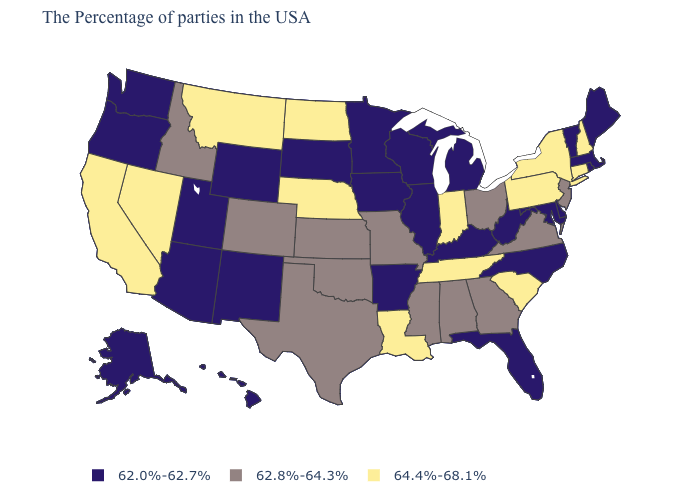Name the states that have a value in the range 62.0%-62.7%?
Short answer required. Maine, Massachusetts, Rhode Island, Vermont, Delaware, Maryland, North Carolina, West Virginia, Florida, Michigan, Kentucky, Wisconsin, Illinois, Arkansas, Minnesota, Iowa, South Dakota, Wyoming, New Mexico, Utah, Arizona, Washington, Oregon, Alaska, Hawaii. Does Pennsylvania have a lower value than Ohio?
Write a very short answer. No. Name the states that have a value in the range 62.0%-62.7%?
Answer briefly. Maine, Massachusetts, Rhode Island, Vermont, Delaware, Maryland, North Carolina, West Virginia, Florida, Michigan, Kentucky, Wisconsin, Illinois, Arkansas, Minnesota, Iowa, South Dakota, Wyoming, New Mexico, Utah, Arizona, Washington, Oregon, Alaska, Hawaii. Name the states that have a value in the range 64.4%-68.1%?
Be succinct. New Hampshire, Connecticut, New York, Pennsylvania, South Carolina, Indiana, Tennessee, Louisiana, Nebraska, North Dakota, Montana, Nevada, California. What is the value of Arizona?
Write a very short answer. 62.0%-62.7%. Does the first symbol in the legend represent the smallest category?
Concise answer only. Yes. What is the value of Connecticut?
Short answer required. 64.4%-68.1%. What is the value of West Virginia?
Quick response, please. 62.0%-62.7%. What is the value of Maine?
Short answer required. 62.0%-62.7%. Which states have the highest value in the USA?
Concise answer only. New Hampshire, Connecticut, New York, Pennsylvania, South Carolina, Indiana, Tennessee, Louisiana, Nebraska, North Dakota, Montana, Nevada, California. Does Colorado have the lowest value in the USA?
Be succinct. No. Name the states that have a value in the range 62.0%-62.7%?
Write a very short answer. Maine, Massachusetts, Rhode Island, Vermont, Delaware, Maryland, North Carolina, West Virginia, Florida, Michigan, Kentucky, Wisconsin, Illinois, Arkansas, Minnesota, Iowa, South Dakota, Wyoming, New Mexico, Utah, Arizona, Washington, Oregon, Alaska, Hawaii. What is the highest value in the South ?
Concise answer only. 64.4%-68.1%. Which states have the highest value in the USA?
Short answer required. New Hampshire, Connecticut, New York, Pennsylvania, South Carolina, Indiana, Tennessee, Louisiana, Nebraska, North Dakota, Montana, Nevada, California. Among the states that border Montana , which have the lowest value?
Write a very short answer. South Dakota, Wyoming. 